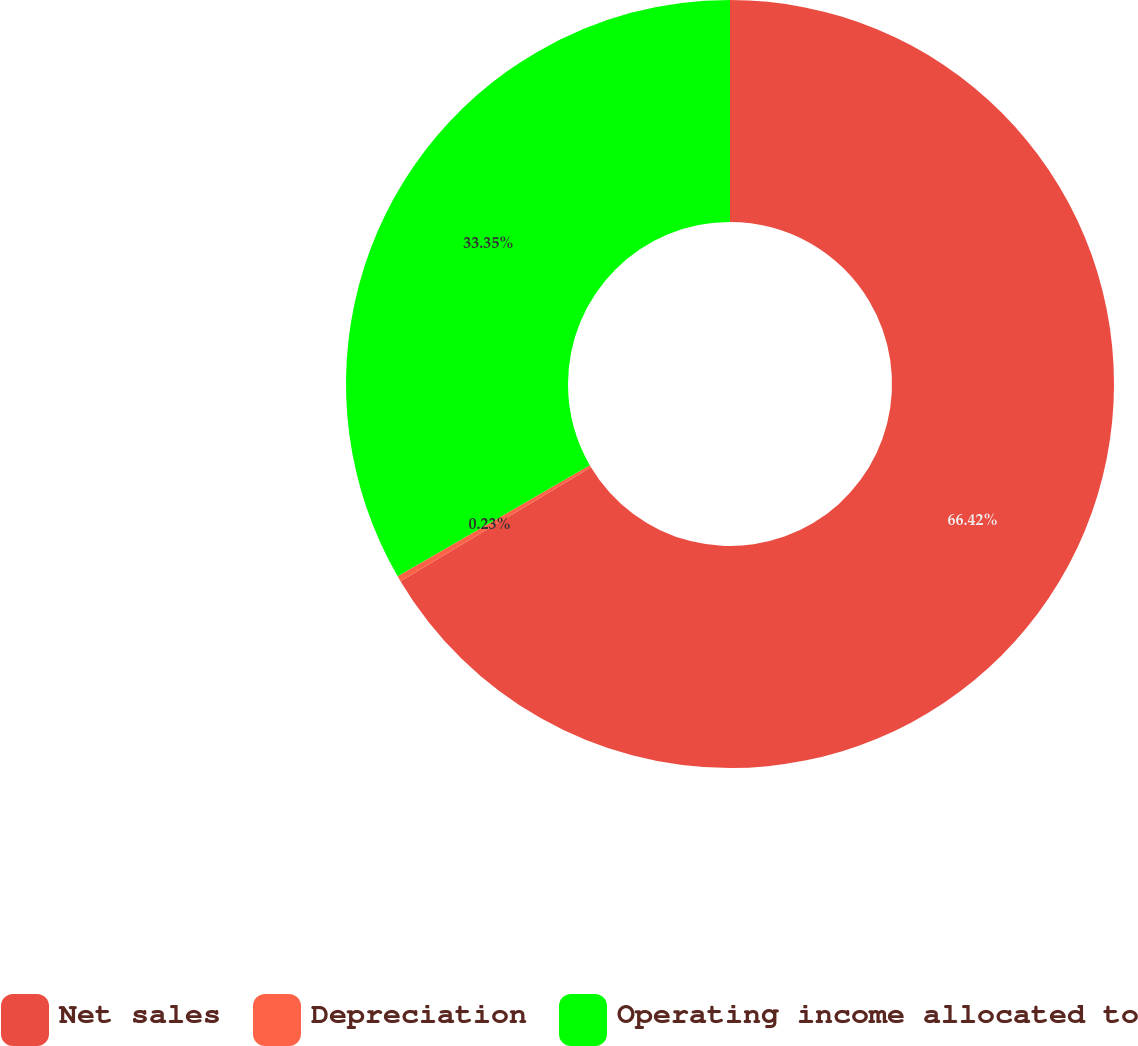Convert chart. <chart><loc_0><loc_0><loc_500><loc_500><pie_chart><fcel>Net sales<fcel>Depreciation<fcel>Operating income allocated to<nl><fcel>66.42%<fcel>0.23%<fcel>33.35%<nl></chart> 